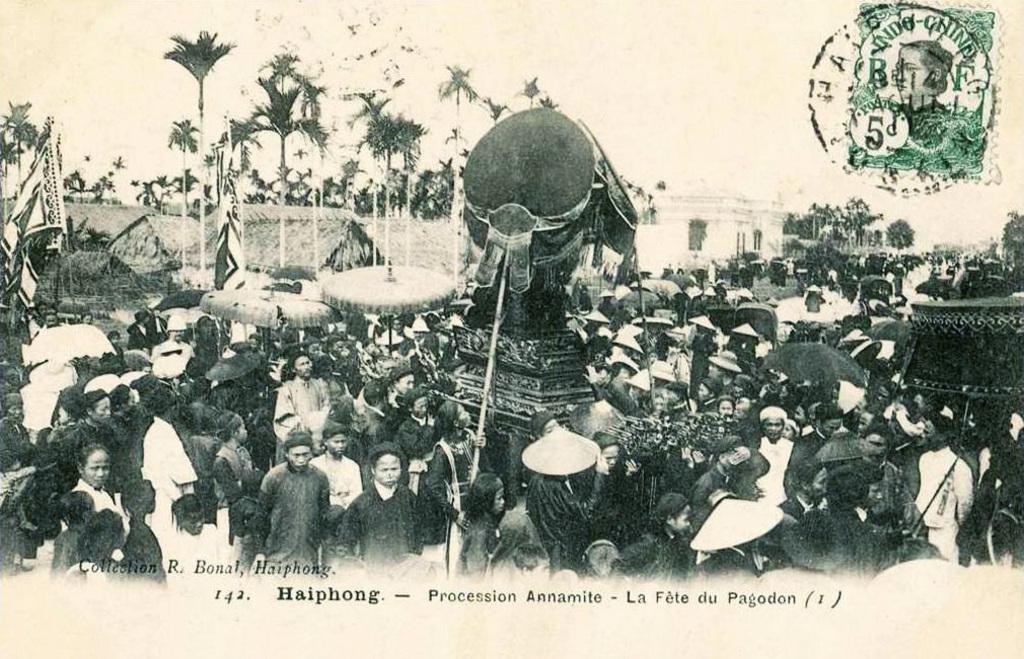Could you give a brief overview of what you see in this image? It is the black and white image in which we can see that there are so many people in the ,middle. In the background there are trees. On the right side there is a building. In the middle there is a statue. On the left side there are flags. It seems to be an old image. 